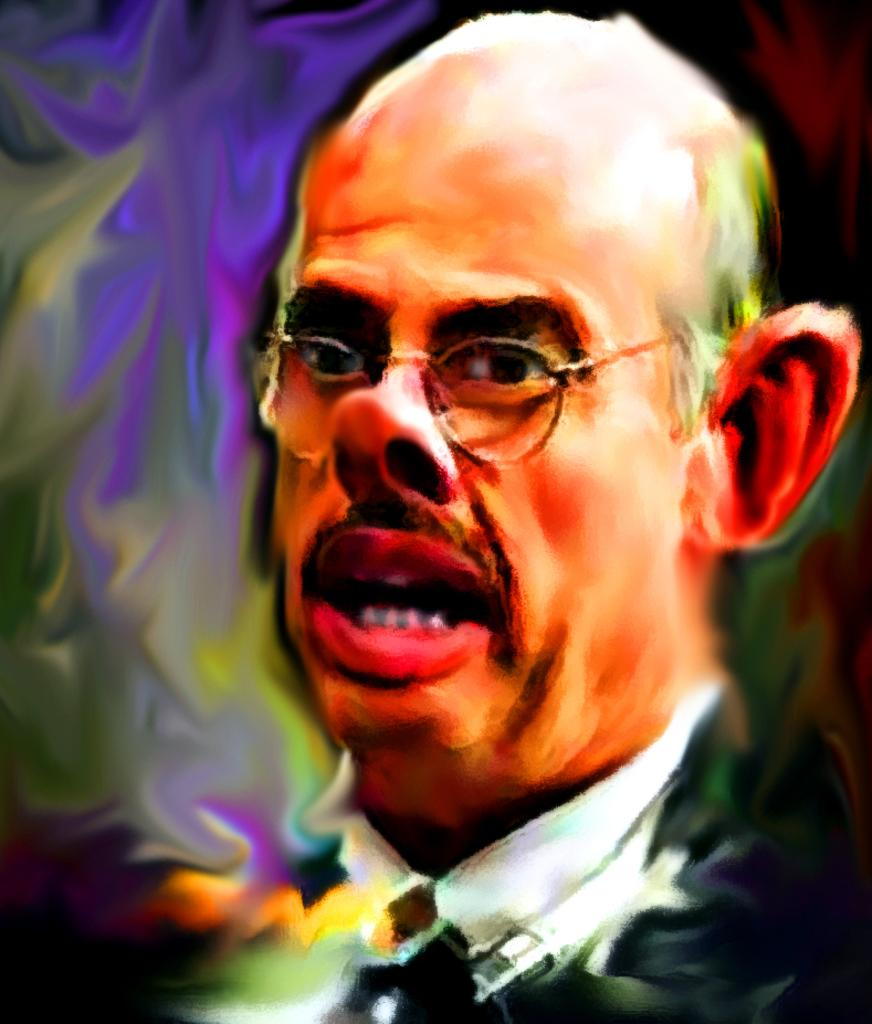What type of artwork is depicted in the image? The image is a painting. What is the main subject of the painting? There is a man's head in the painting. What accessory is the man wearing in the painting? The man is wearing spectacles. How would you describe the background of the painting? The background of the painting is colorful. What hobbies does the man in the painting enjoy? There is no information about the man's hobbies in the image, as it only shows his head and spectacles. How many dogs are present in the painting? There are no dogs present in the painting; it only features a man's head and spectacles. 